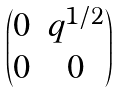Convert formula to latex. <formula><loc_0><loc_0><loc_500><loc_500>\begin{pmatrix} 0 & q ^ { 1 / 2 } \\ 0 & 0 \end{pmatrix}</formula> 